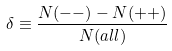Convert formula to latex. <formula><loc_0><loc_0><loc_500><loc_500>\delta \equiv \frac { N ( - - ) - N ( + + ) } { N ( a l l ) }</formula> 